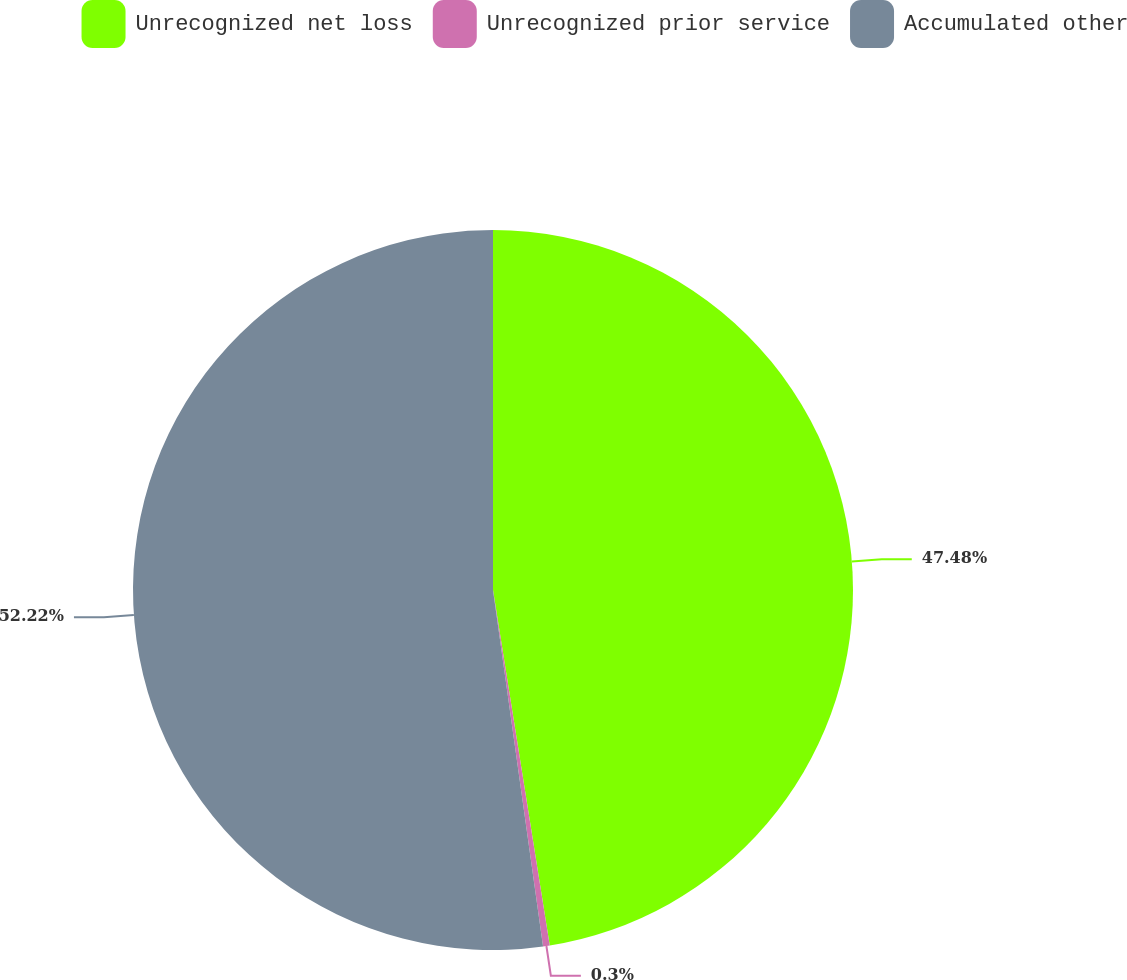Convert chart. <chart><loc_0><loc_0><loc_500><loc_500><pie_chart><fcel>Unrecognized net loss<fcel>Unrecognized prior service<fcel>Accumulated other<nl><fcel>47.48%<fcel>0.3%<fcel>52.22%<nl></chart> 